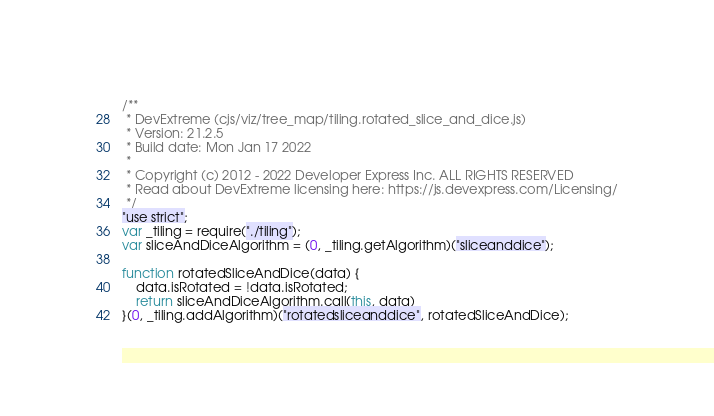Convert code to text. <code><loc_0><loc_0><loc_500><loc_500><_JavaScript_>/**
 * DevExtreme (cjs/viz/tree_map/tiling.rotated_slice_and_dice.js)
 * Version: 21.2.5
 * Build date: Mon Jan 17 2022
 *
 * Copyright (c) 2012 - 2022 Developer Express Inc. ALL RIGHTS RESERVED
 * Read about DevExtreme licensing here: https://js.devexpress.com/Licensing/
 */
"use strict";
var _tiling = require("./tiling");
var sliceAndDiceAlgorithm = (0, _tiling.getAlgorithm)("sliceanddice");

function rotatedSliceAndDice(data) {
    data.isRotated = !data.isRotated;
    return sliceAndDiceAlgorithm.call(this, data)
}(0, _tiling.addAlgorithm)("rotatedsliceanddice", rotatedSliceAndDice);
</code> 